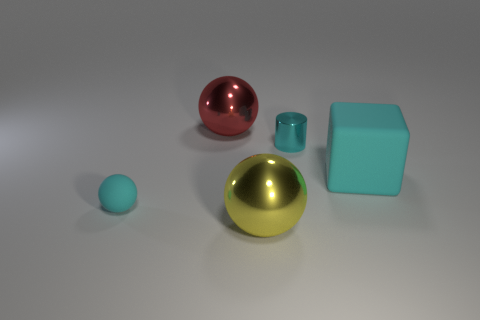Add 2 big green matte spheres. How many objects exist? 7 Subtract all cylinders. How many objects are left? 4 Subtract all big gray metallic objects. Subtract all cyan rubber blocks. How many objects are left? 4 Add 5 red shiny objects. How many red shiny objects are left? 6 Add 5 red metal things. How many red metal things exist? 6 Subtract 0 red blocks. How many objects are left? 5 